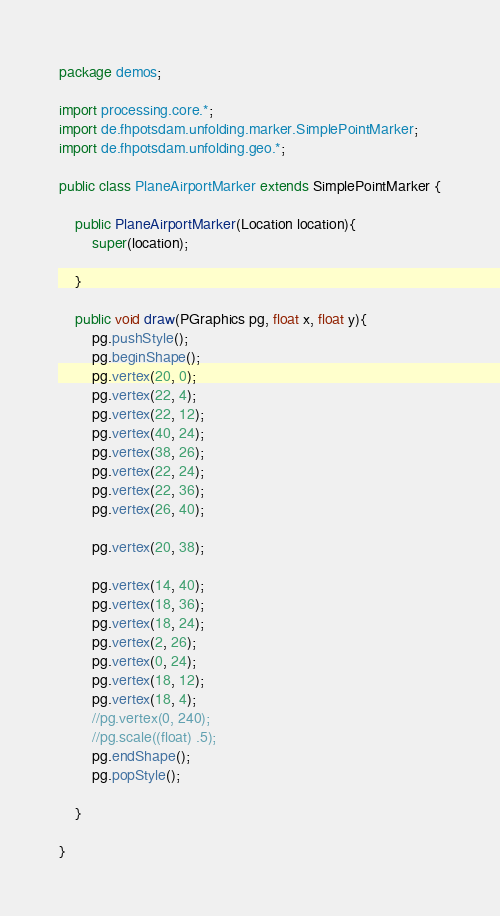<code> <loc_0><loc_0><loc_500><loc_500><_Java_>package demos;

import processing.core.*;
import de.fhpotsdam.unfolding.marker.SimplePointMarker;
import de.fhpotsdam.unfolding.geo.*;

public class PlaneAirportMarker extends SimplePointMarker {
	
	public PlaneAirportMarker(Location location){
		super(location);
		
	}
	
	public void draw(PGraphics pg, float x, float y){
		pg.pushStyle();
		pg.beginShape();
		pg.vertex(20, 0);
		pg.vertex(22, 4);
		pg.vertex(22, 12);
		pg.vertex(40, 24);
		pg.vertex(38, 26);
		pg.vertex(22, 24);
		pg.vertex(22, 36);
		pg.vertex(26, 40);
		
		pg.vertex(20, 38);
		
		pg.vertex(14, 40);
		pg.vertex(18, 36);
		pg.vertex(18, 24);
		pg.vertex(2, 26);
		pg.vertex(0, 24);
		pg.vertex(18, 12);
		pg.vertex(18, 4);
		//pg.vertex(0, 240);
		//pg.scale((float) .5);
		pg.endShape();
		pg.popStyle();
		
	}

}
</code> 